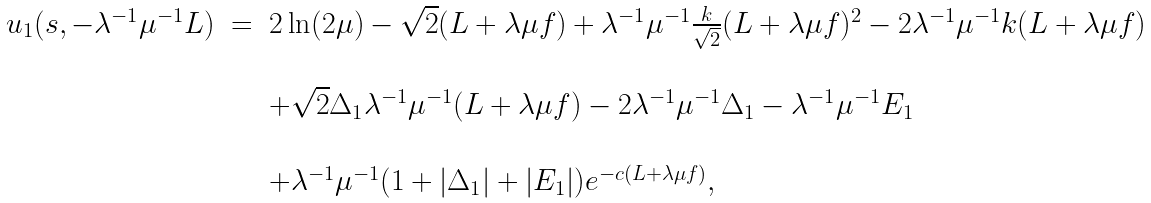<formula> <loc_0><loc_0><loc_500><loc_500>\begin{array} { l l l } u _ { 1 } ( s , - \lambda ^ { - 1 } \mu ^ { - 1 } L ) & = & 2 \ln ( 2 \mu ) - \sqrt { 2 } ( L + \lambda \mu f ) + \lambda ^ { - 1 } \mu ^ { - 1 } \frac { k } { \sqrt { 2 } } ( L + \lambda \mu f ) ^ { 2 } - 2 \lambda ^ { - 1 } \mu ^ { - 1 } k ( L + \lambda \mu f ) \\ & & \\ & & + \sqrt { 2 } \Delta _ { 1 } \lambda ^ { - 1 } \mu ^ { - 1 } ( L + \lambda \mu f ) - 2 \lambda ^ { - 1 } \mu ^ { - 1 } \Delta _ { 1 } - \lambda ^ { - 1 } \mu ^ { - 1 } E _ { 1 } \\ & & \\ & & + \lambda ^ { - 1 } \mu ^ { - 1 } ( 1 + | \Delta _ { 1 } | + | E _ { 1 } | ) e ^ { - c ( L + \lambda \mu f ) } , \end{array}</formula> 